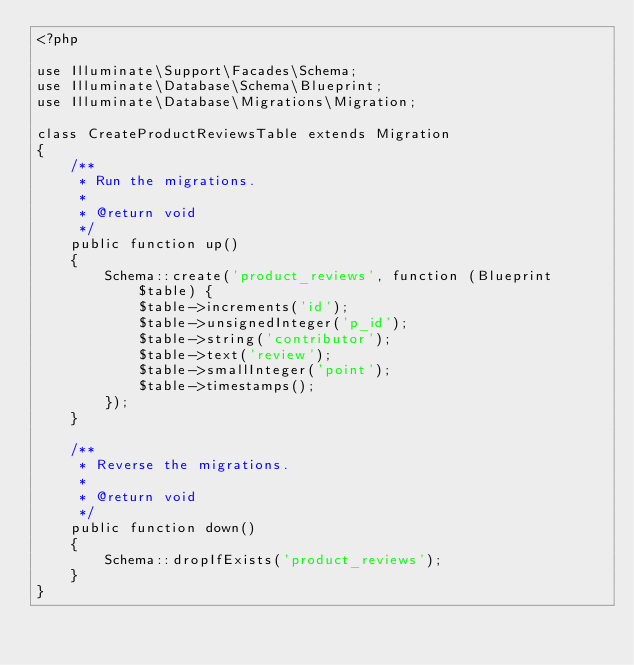Convert code to text. <code><loc_0><loc_0><loc_500><loc_500><_PHP_><?php

use Illuminate\Support\Facades\Schema;
use Illuminate\Database\Schema\Blueprint;
use Illuminate\Database\Migrations\Migration;

class CreateProductReviewsTable extends Migration
{
    /**
     * Run the migrations.
     *
     * @return void
     */
    public function up()
    {
        Schema::create('product_reviews', function (Blueprint $table) {
            $table->increments('id');
            $table->unsignedInteger('p_id');
            $table->string('contributor');
            $table->text('review');
            $table->smallInteger('point');
            $table->timestamps();
        });
    }

    /**
     * Reverse the migrations.
     *
     * @return void
     */
    public function down()
    {
        Schema::dropIfExists('product_reviews');
    }
}
</code> 